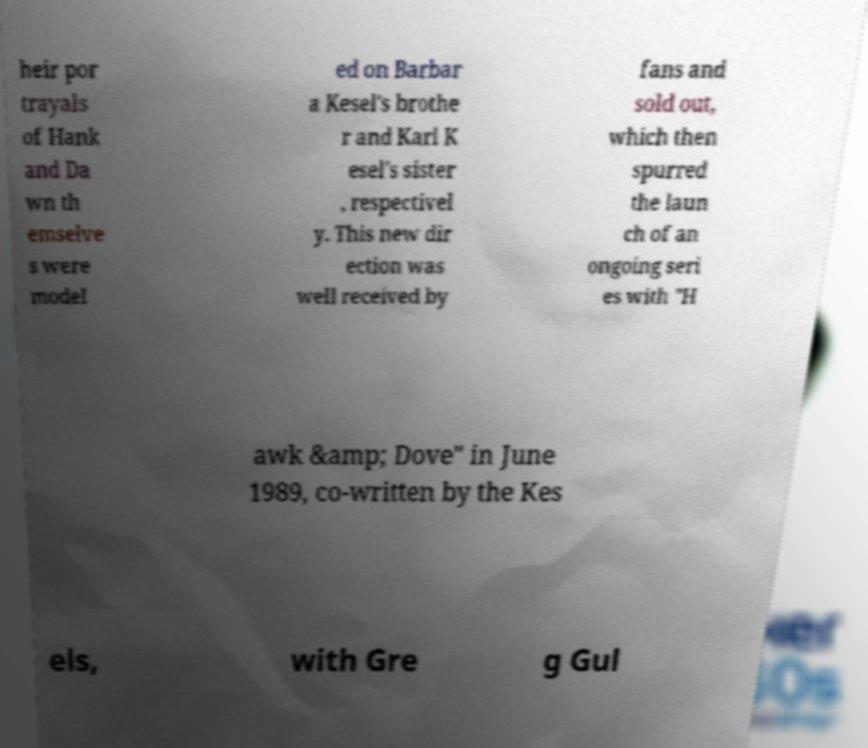There's text embedded in this image that I need extracted. Can you transcribe it verbatim? heir por trayals of Hank and Da wn th emselve s were model ed on Barbar a Kesel's brothe r and Karl K esel's sister , respectivel y. This new dir ection was well received by fans and sold out, which then spurred the laun ch of an ongoing seri es with "H awk &amp; Dove" in June 1989, co-written by the Kes els, with Gre g Gul 